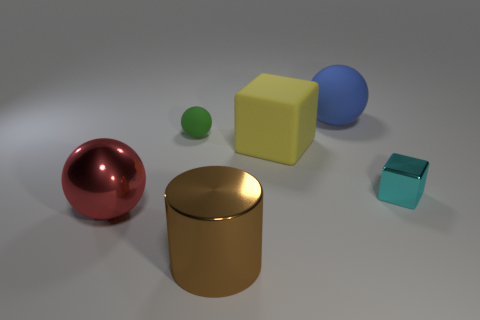How many small rubber balls are right of the tiny shiny block?
Your response must be concise. 0. What number of objects are either large yellow blocks or tiny red metal cubes?
Provide a short and direct response. 1. There is a thing that is on the left side of the big brown shiny thing and in front of the small metallic thing; what is its shape?
Your answer should be compact. Sphere. How many big green rubber cylinders are there?
Provide a succinct answer. 0. What is the color of the ball that is the same material as the cylinder?
Offer a terse response. Red. Is the number of green shiny cylinders greater than the number of green matte spheres?
Your answer should be very brief. No. There is a ball that is both behind the yellow matte thing and on the left side of the blue rubber thing; what is its size?
Your response must be concise. Small. Are there an equal number of blue balls that are behind the large brown cylinder and large red objects?
Give a very brief answer. Yes. Does the blue matte sphere have the same size as the cyan cube?
Offer a very short reply. No. There is a big thing that is behind the red shiny object and in front of the large blue rubber thing; what is its color?
Provide a short and direct response. Yellow. 